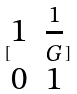Convert formula to latex. <formula><loc_0><loc_0><loc_500><loc_500>[ \begin{matrix} 1 & \frac { 1 } { G } \\ 0 & 1 \end{matrix} ]</formula> 